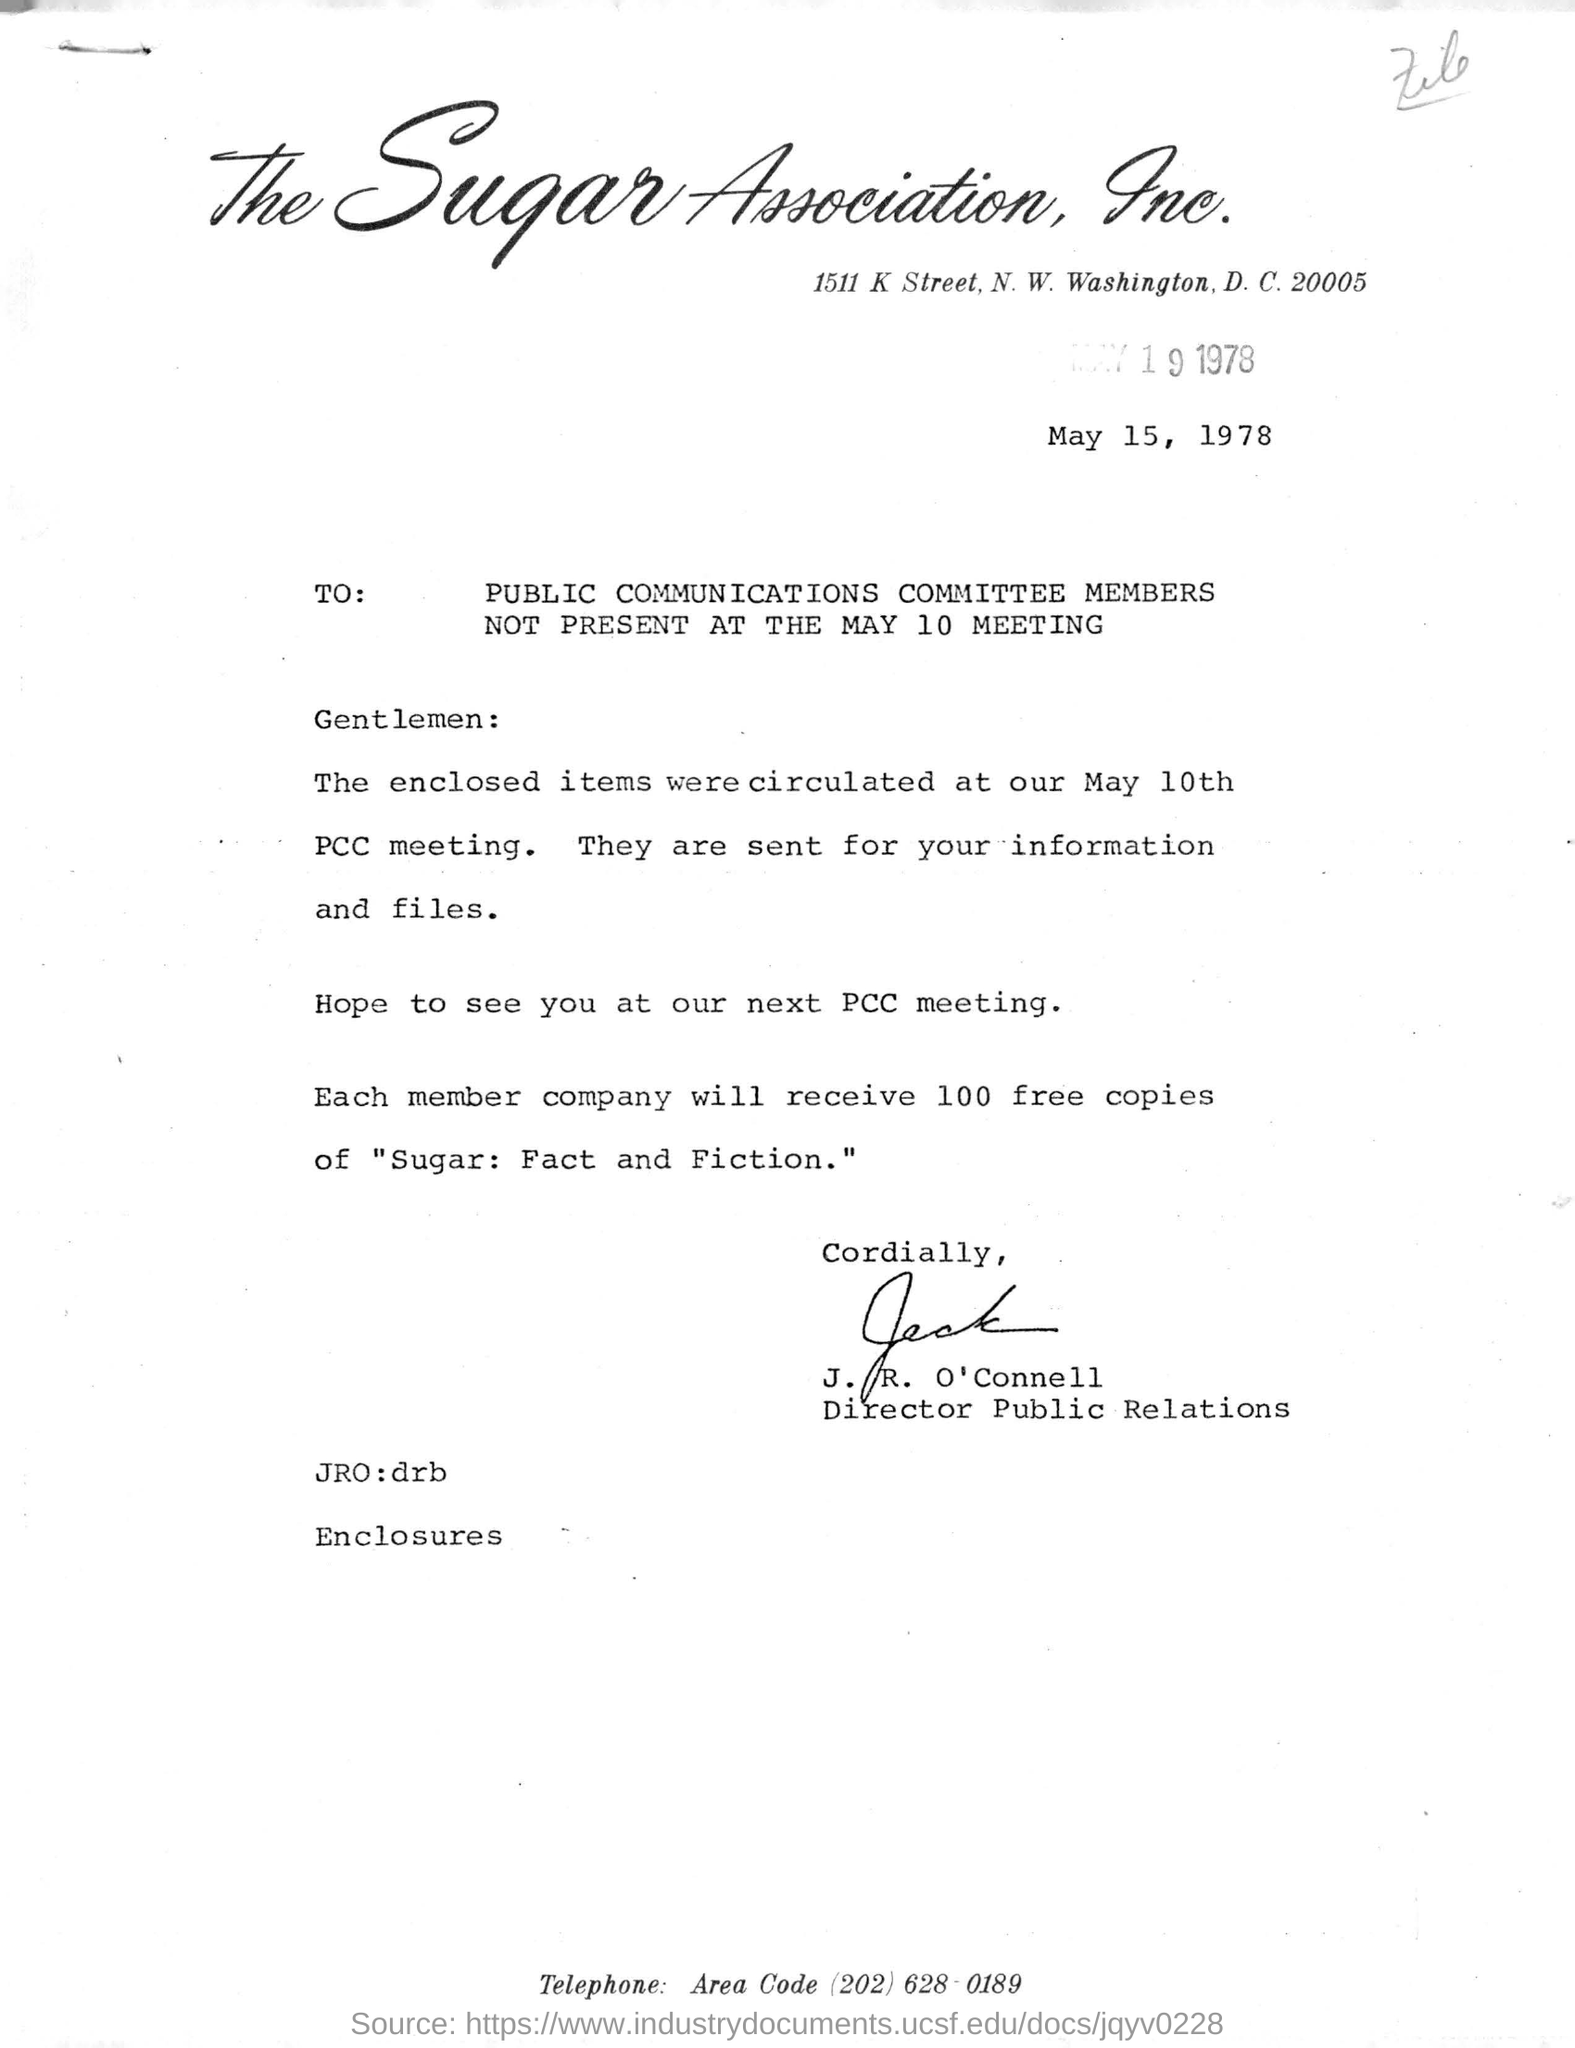Who is the sender of this letter?
Make the answer very short. J. R. O'Connell. What is the designation of J. R. O' Connell?
Your answer should be compact. Director Public Relations. How many free copies of "Sugar: Fact and Fiction. " will each member company receive?
Provide a succinct answer. 100 free copies. To whom the letter is being addressed to ?
Keep it short and to the point. Public Communications Committee Members Not Present at the May 10 Meeting. 